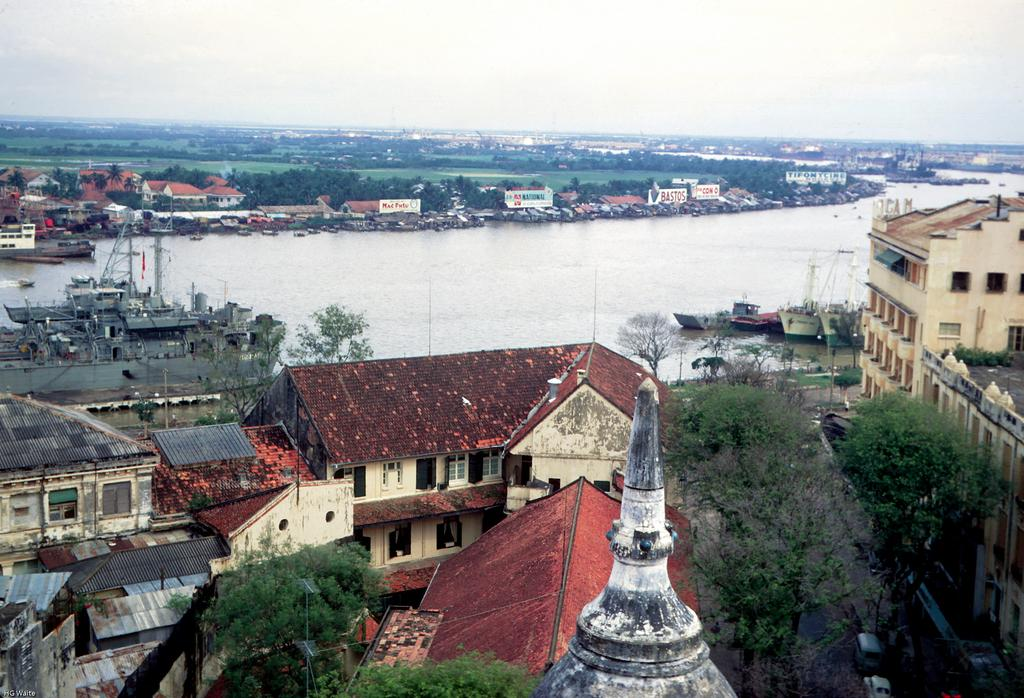What type of structures can be seen in the image? There are houses in the image. What other natural elements are present in the image? There are trees in the image. What can be seen on the water in the image? There are boats on the water in the image. What type of transportation is visible in the image? There are vehicles in the image. What is the surface on which the vehicles are traveling? There is a road in the image. What is visible in the background of the image? The sky is visible in the background of the image. Can you tell me how many airplanes are flying over the houses in the image? There are no airplanes visible in the image; it only shows houses, trees, boats, vehicles, a road, and the sky. What type of rest can be seen in the image? There is no rest or resting area depicted in the image. 